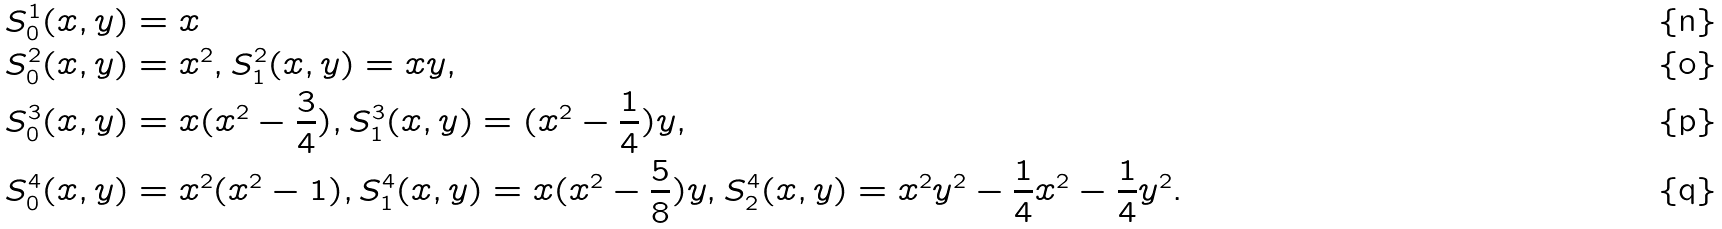<formula> <loc_0><loc_0><loc_500><loc_500>& S _ { 0 } ^ { 1 } ( x , y ) = x \\ & S _ { 0 } ^ { 2 } ( x , y ) = x ^ { 2 } , S _ { 1 } ^ { 2 } ( x , y ) = x y , \\ & S _ { 0 } ^ { 3 } ( x , y ) = x ( x ^ { 2 } - \frac { 3 } { 4 } ) , S _ { 1 } ^ { 3 } ( x , y ) = ( x ^ { 2 } - \frac { 1 } { 4 } ) y , \\ & S _ { 0 } ^ { 4 } ( x , y ) = x ^ { 2 } ( x ^ { 2 } - 1 ) , S _ { 1 } ^ { 4 } ( x , y ) = x ( x ^ { 2 } - \frac { 5 } { 8 } ) y , S _ { 2 } ^ { 4 } ( x , y ) = x ^ { 2 } y ^ { 2 } - \frac { 1 } { 4 } x ^ { 2 } - \frac { 1 } { 4 } y ^ { 2 } .</formula> 